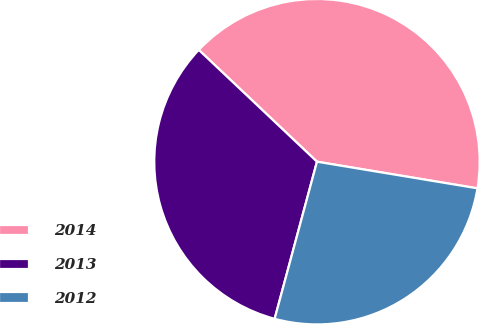Convert chart to OTSL. <chart><loc_0><loc_0><loc_500><loc_500><pie_chart><fcel>2014<fcel>2013<fcel>2012<nl><fcel>40.56%<fcel>32.87%<fcel>26.57%<nl></chart> 